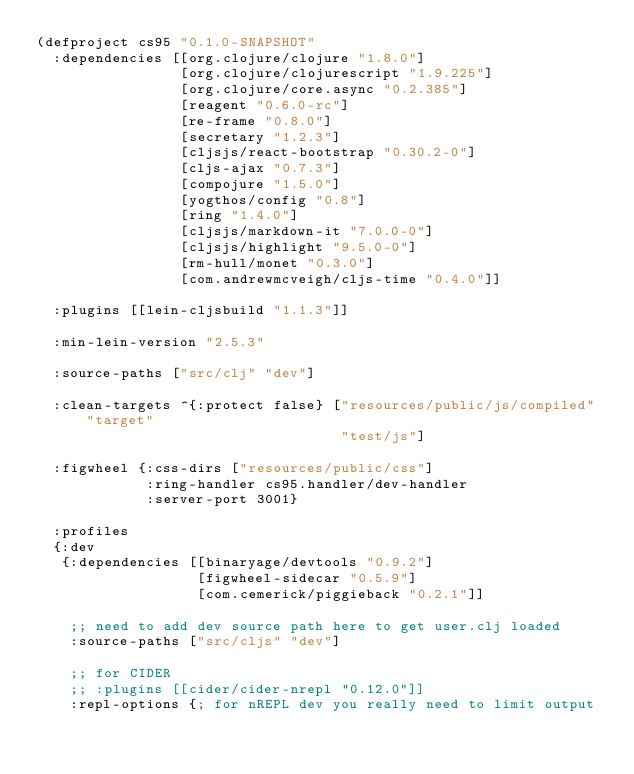<code> <loc_0><loc_0><loc_500><loc_500><_Clojure_>(defproject cs95 "0.1.0-SNAPSHOT"
  :dependencies [[org.clojure/clojure "1.8.0"]
                 [org.clojure/clojurescript "1.9.225"]
                 [org.clojure/core.async "0.2.385"]
                 [reagent "0.6.0-rc"]
                 [re-frame "0.8.0"]
                 [secretary "1.2.3"]
                 [cljsjs/react-bootstrap "0.30.2-0"]
                 [cljs-ajax "0.7.3"]
                 [compojure "1.5.0"]
                 [yogthos/config "0.8"]
                 [ring "1.4.0"]
                 [cljsjs/markdown-it "7.0.0-0"]
                 [cljsjs/highlight "9.5.0-0"]
                 [rm-hull/monet "0.3.0"]
                 [com.andrewmcveigh/cljs-time "0.4.0"]]

  :plugins [[lein-cljsbuild "1.1.3"]]

  :min-lein-version "2.5.3"

  :source-paths ["src/clj" "dev"]

  :clean-targets ^{:protect false} ["resources/public/js/compiled" "target"
                                    "test/js"]

  :figwheel {:css-dirs ["resources/public/css"]
             :ring-handler cs95.handler/dev-handler
             :server-port 3001}

  :profiles
  {:dev
   {:dependencies [[binaryage/devtools "0.9.2"]
                   [figwheel-sidecar "0.5.9"]
                   [com.cemerick/piggieback "0.2.1"]]

    ;; need to add dev source path here to get user.clj loaded
    :source-paths ["src/cljs" "dev"]

    ;; for CIDER
    ;; :plugins [[cider/cider-nrepl "0.12.0"]]
    :repl-options {; for nREPL dev you really need to limit output</code> 